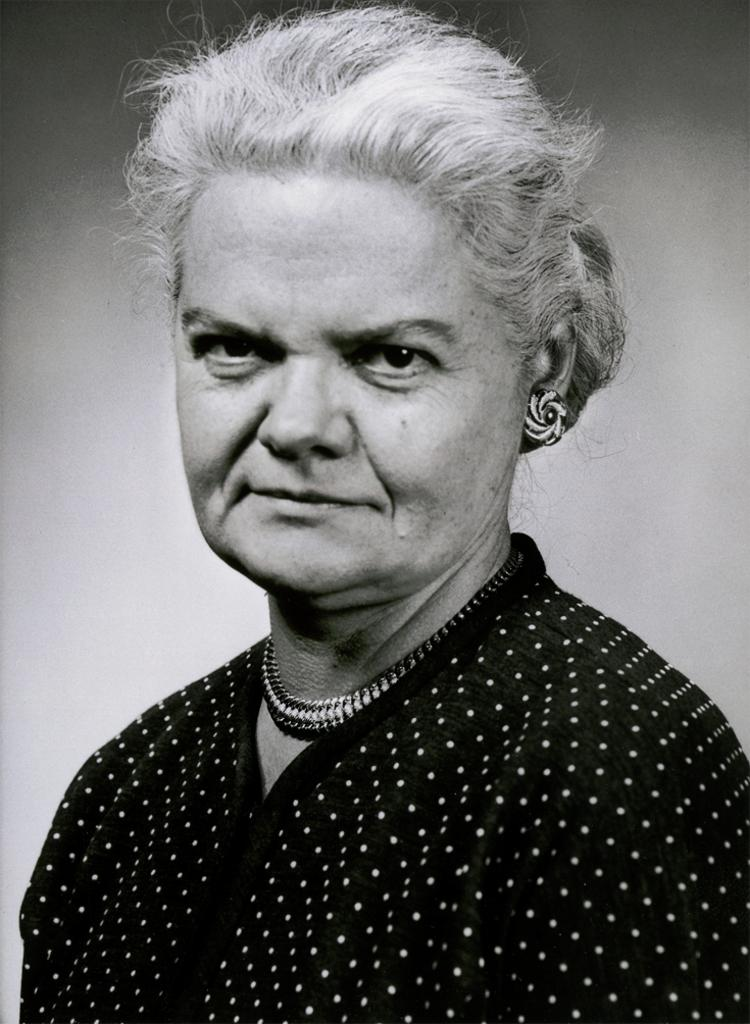What is the color scheme of the image? The image is black and white. What is the main subject of the image? There is a picture of a woman in the image. What type of appliance is the woman using in the image? There is no appliance present in the image, as it is a black and white picture of a woman. What is the woman teaching in the image? There is no indication of teaching in the image, as it only features a picture of a woman. 